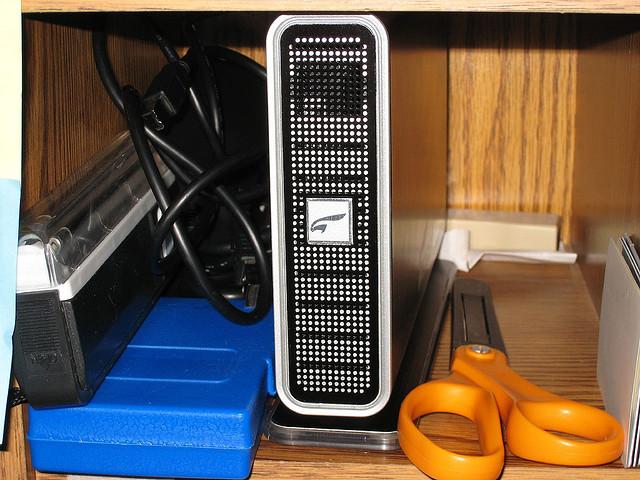Which item here would beat paper?
Quick response, please. Scissors. What is the item in the middle of the image used for?
Answer briefly. Cutting. What color are the scissor handles?
Give a very brief answer. Orange. 